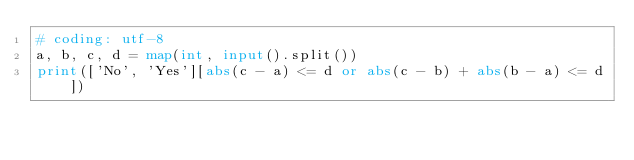<code> <loc_0><loc_0><loc_500><loc_500><_Python_># coding: utf-8
a, b, c, d = map(int, input().split())
print(['No', 'Yes'][abs(c - a) <= d or abs(c - b) + abs(b - a) <= d])</code> 